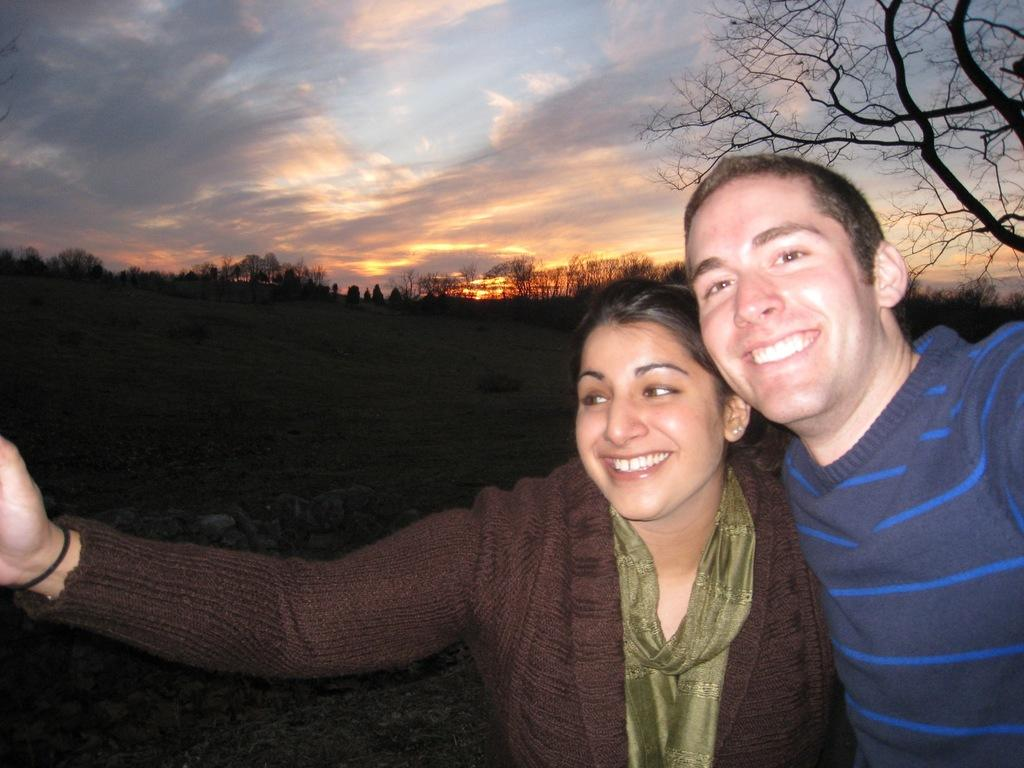How many people are present in the image? There are two people, a man and a woman, present in the image. What are the people in the image doing? Both the man and the woman are standing and smiling. What can be seen in the background of the image? There are trees and the sky visible in the background of the image. What type of food is being prepared in the river in the image? There is no river or food preparation present in the image. 